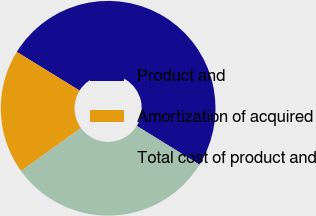Convert chart. <chart><loc_0><loc_0><loc_500><loc_500><pie_chart><fcel>Product and<fcel>Amortization of acquired<fcel>Total cost of product and<nl><fcel>50.0%<fcel>18.75%<fcel>31.25%<nl></chart> 